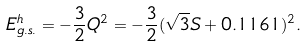<formula> <loc_0><loc_0><loc_500><loc_500>E ^ { h } _ { g . s . } = - { \frac { 3 } { 2 } } Q ^ { 2 } = - { \frac { 3 } { 2 } } ( \sqrt { 3 } S + 0 . 1 1 6 1 ) ^ { 2 } .</formula> 